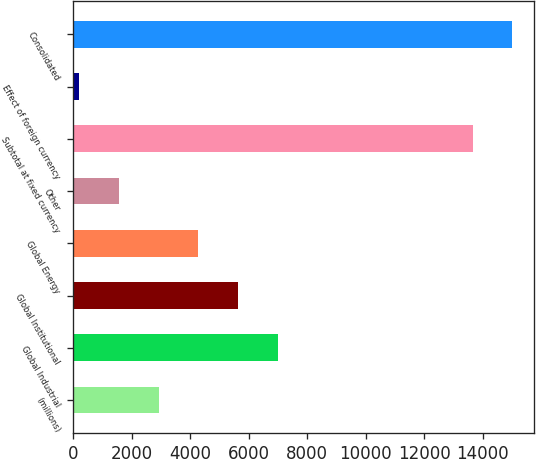Convert chart to OTSL. <chart><loc_0><loc_0><loc_500><loc_500><bar_chart><fcel>(millions)<fcel>Global Industrial<fcel>Global Institutional<fcel>Global Energy<fcel>Other<fcel>Subtotal at fixed currency<fcel>Effect of foreign currency<fcel>Consolidated<nl><fcel>2921.34<fcel>7015.2<fcel>5650.58<fcel>4285.96<fcel>1556.72<fcel>13646.2<fcel>192.1<fcel>15010.8<nl></chart> 